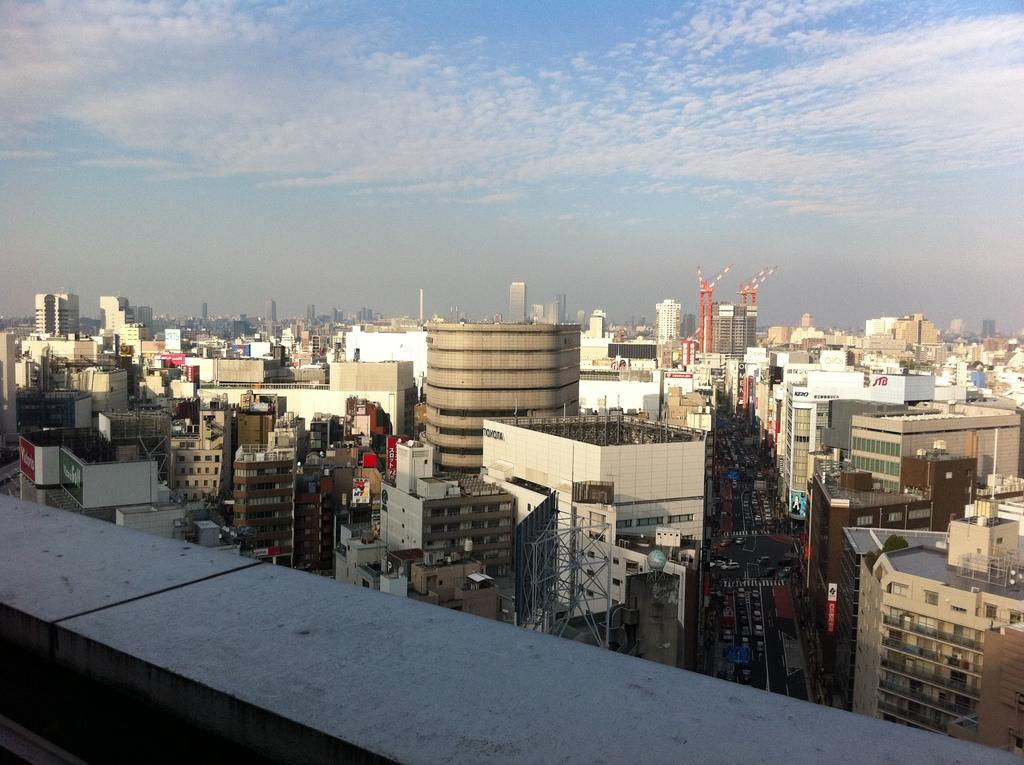What type of structures can be seen in the image? The image contains many buildings and skyscrapers. What can be seen in the sky in the image? There are clouds visible in the sky. From where might the image have been taken? The image was likely taken from a terrace. How many sheep are visible in the image? There are no sheep present in the image. What is the friction between the buildings in the image? The concept of friction does not apply to buildings in an image; it is a property related to physical interactions between objects. 